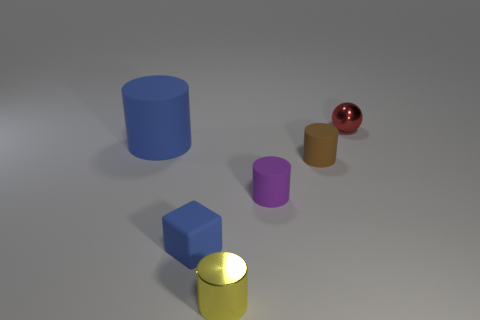Is the color of the large rubber cylinder the same as the small cylinder that is behind the purple matte cylinder?
Provide a succinct answer. No. What number of tiny red metallic spheres are there?
Ensure brevity in your answer.  1. Is there a small ball that has the same color as the small metallic cylinder?
Keep it short and to the point. No. There is a tiny rubber object that is on the left side of the metal object that is in front of the tiny shiny thing behind the purple cylinder; what is its color?
Offer a very short reply. Blue. Does the tiny yellow cylinder have the same material as the tiny brown thing behind the tiny blue object?
Offer a very short reply. No. What material is the cube?
Give a very brief answer. Rubber. There is a large object that is the same color as the block; what is its material?
Provide a short and direct response. Rubber. What number of other things are the same material as the tiny purple thing?
Provide a succinct answer. 3. What is the shape of the small object that is both to the right of the tiny blue rubber cube and in front of the small purple thing?
Provide a succinct answer. Cylinder. There is a cylinder that is the same material as the small red sphere; what is its color?
Your response must be concise. Yellow. 